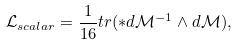<formula> <loc_0><loc_0><loc_500><loc_500>\mathcal { L } _ { s c a l a r } = \frac { 1 } { 1 6 } t r ( \ast d \mathcal { M } ^ { - 1 } \wedge d \mathcal { M } ) ,</formula> 